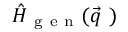Convert formula to latex. <formula><loc_0><loc_0><loc_500><loc_500>\hat { H } _ { g e n } ( \vec { q } \ )</formula> 